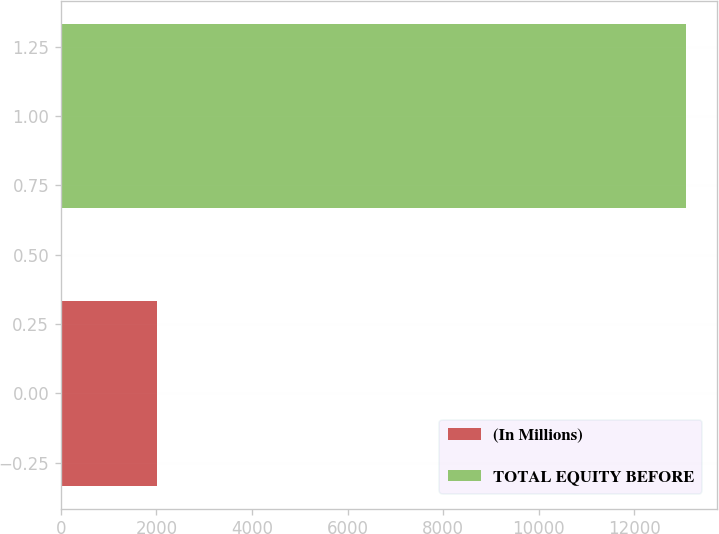Convert chart to OTSL. <chart><loc_0><loc_0><loc_500><loc_500><bar_chart><fcel>(In Millions)<fcel>TOTAL EQUITY BEFORE<nl><fcel>2015<fcel>13086<nl></chart> 